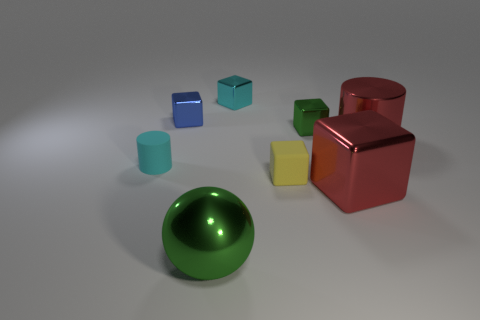Subtract all yellow blocks. How many blocks are left? 4 Subtract all tiny blue metal cubes. How many cubes are left? 4 Subtract 1 cubes. How many cubes are left? 4 Subtract all brown cubes. Subtract all cyan cylinders. How many cubes are left? 5 Add 2 matte cubes. How many objects exist? 10 Subtract all cylinders. How many objects are left? 6 Add 2 yellow blocks. How many yellow blocks exist? 3 Subtract 1 green cubes. How many objects are left? 7 Subtract all small cyan rubber cylinders. Subtract all big red cylinders. How many objects are left? 6 Add 3 tiny green metal things. How many tiny green metal things are left? 4 